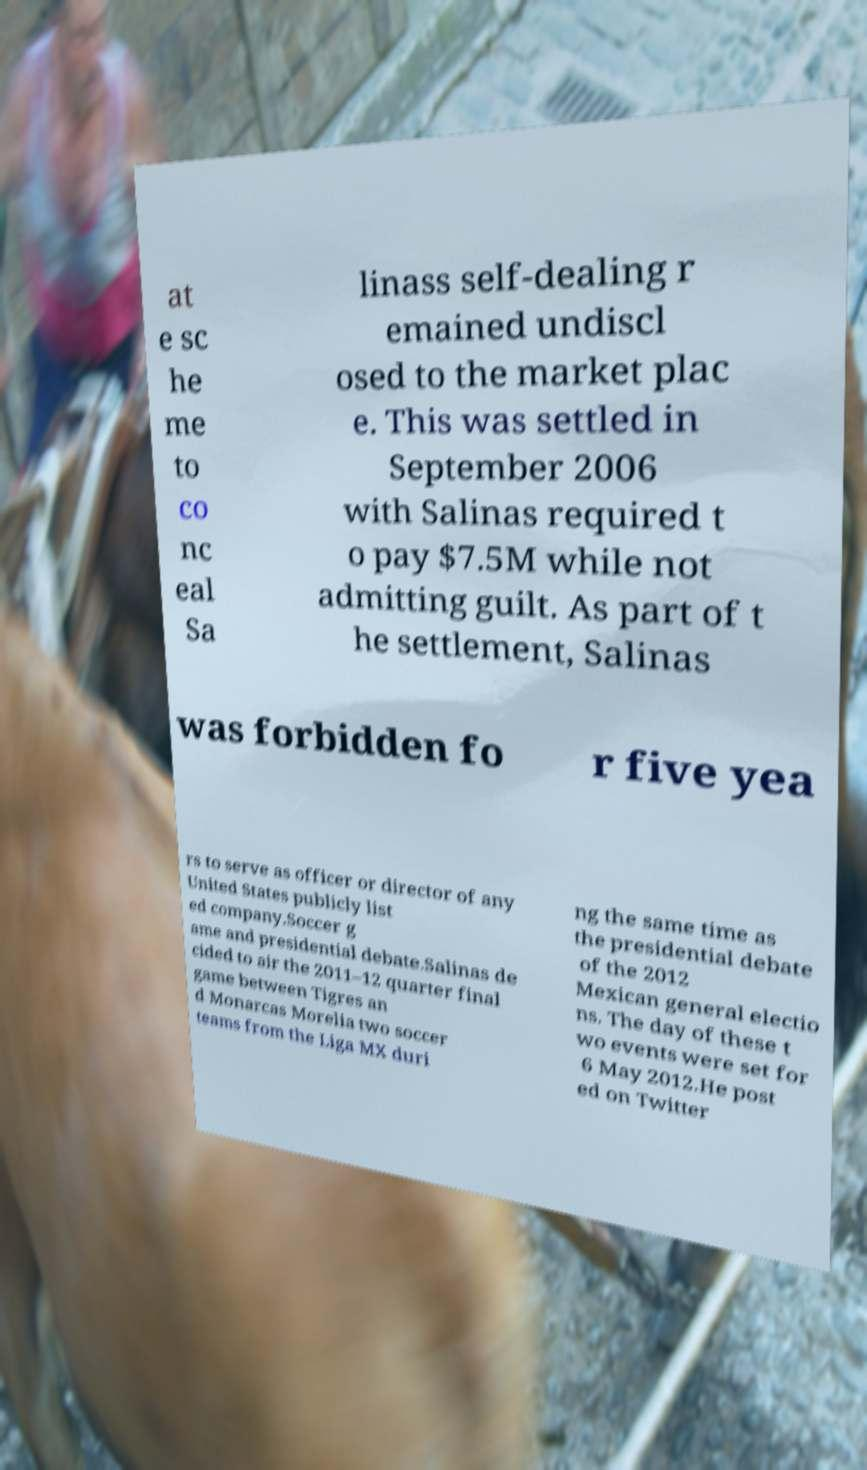There's text embedded in this image that I need extracted. Can you transcribe it verbatim? at e sc he me to co nc eal Sa linass self-dealing r emained undiscl osed to the market plac e. This was settled in September 2006 with Salinas required t o pay $7.5M while not admitting guilt. As part of t he settlement, Salinas was forbidden fo r five yea rs to serve as officer or director of any United States publicly list ed company.Soccer g ame and presidential debate.Salinas de cided to air the 2011–12 quarter final game between Tigres an d Monarcas Morelia two soccer teams from the Liga MX duri ng the same time as the presidential debate of the 2012 Mexican general electio ns. The day of these t wo events were set for 6 May 2012.He post ed on Twitter 